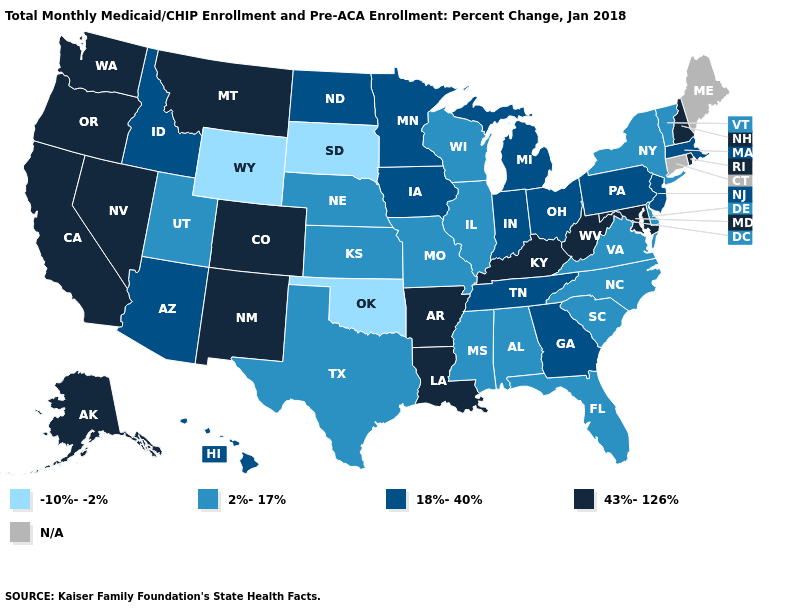Name the states that have a value in the range 43%-126%?
Concise answer only. Alaska, Arkansas, California, Colorado, Kentucky, Louisiana, Maryland, Montana, Nevada, New Hampshire, New Mexico, Oregon, Rhode Island, Washington, West Virginia. What is the value of Oklahoma?
Write a very short answer. -10%--2%. What is the lowest value in the South?
Answer briefly. -10%--2%. What is the value of Wyoming?
Quick response, please. -10%--2%. Name the states that have a value in the range 43%-126%?
Write a very short answer. Alaska, Arkansas, California, Colorado, Kentucky, Louisiana, Maryland, Montana, Nevada, New Hampshire, New Mexico, Oregon, Rhode Island, Washington, West Virginia. What is the value of Louisiana?
Quick response, please. 43%-126%. Name the states that have a value in the range 43%-126%?
Give a very brief answer. Alaska, Arkansas, California, Colorado, Kentucky, Louisiana, Maryland, Montana, Nevada, New Hampshire, New Mexico, Oregon, Rhode Island, Washington, West Virginia. Name the states that have a value in the range N/A?
Answer briefly. Connecticut, Maine. Name the states that have a value in the range -10%--2%?
Short answer required. Oklahoma, South Dakota, Wyoming. Among the states that border Utah , does Wyoming have the lowest value?
Short answer required. Yes. Does the first symbol in the legend represent the smallest category?
Be succinct. Yes. Name the states that have a value in the range N/A?
Short answer required. Connecticut, Maine. Which states have the highest value in the USA?
Concise answer only. Alaska, Arkansas, California, Colorado, Kentucky, Louisiana, Maryland, Montana, Nevada, New Hampshire, New Mexico, Oregon, Rhode Island, Washington, West Virginia. 